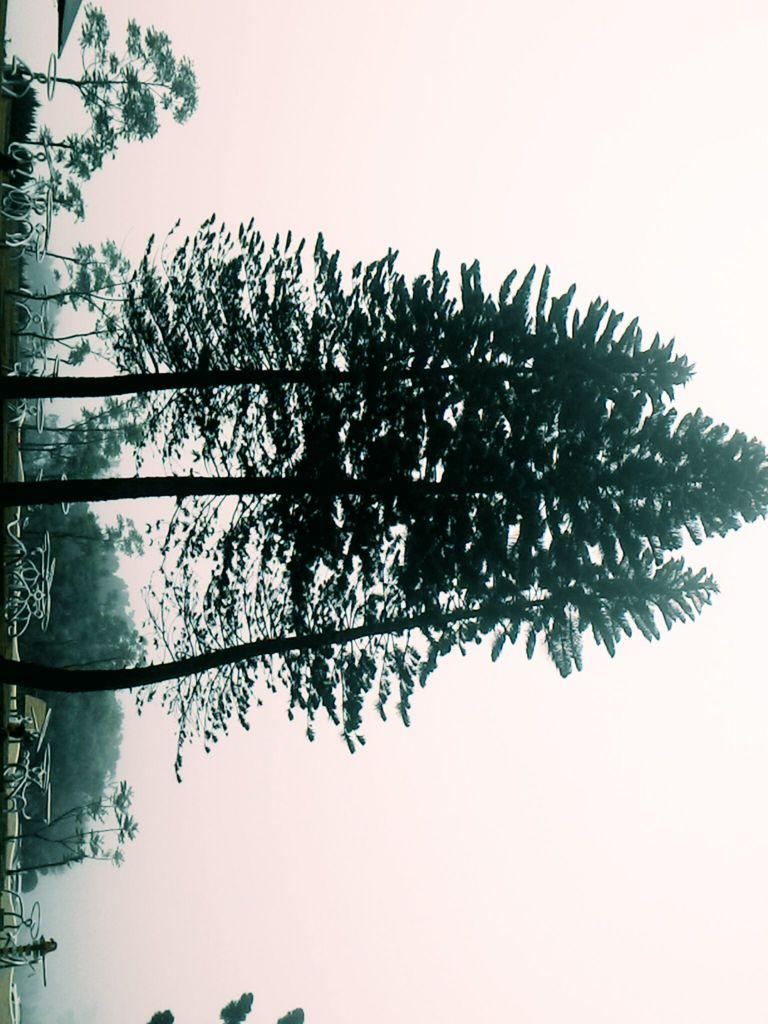What type of vegetation can be seen in the image? There are trees in the image. What is located behind the trees in the image? There are tables behind the trees in the image. What part of the natural environment is visible in the image? The sky is visible to the right in the image. What type of engine can be seen powering the apparatus in the image? There is no engine or apparatus present in the image; it features trees and tables. How many ears can be seen on the person in the image? There is no person present in the image, so it is not possible to determine the number of ears. 